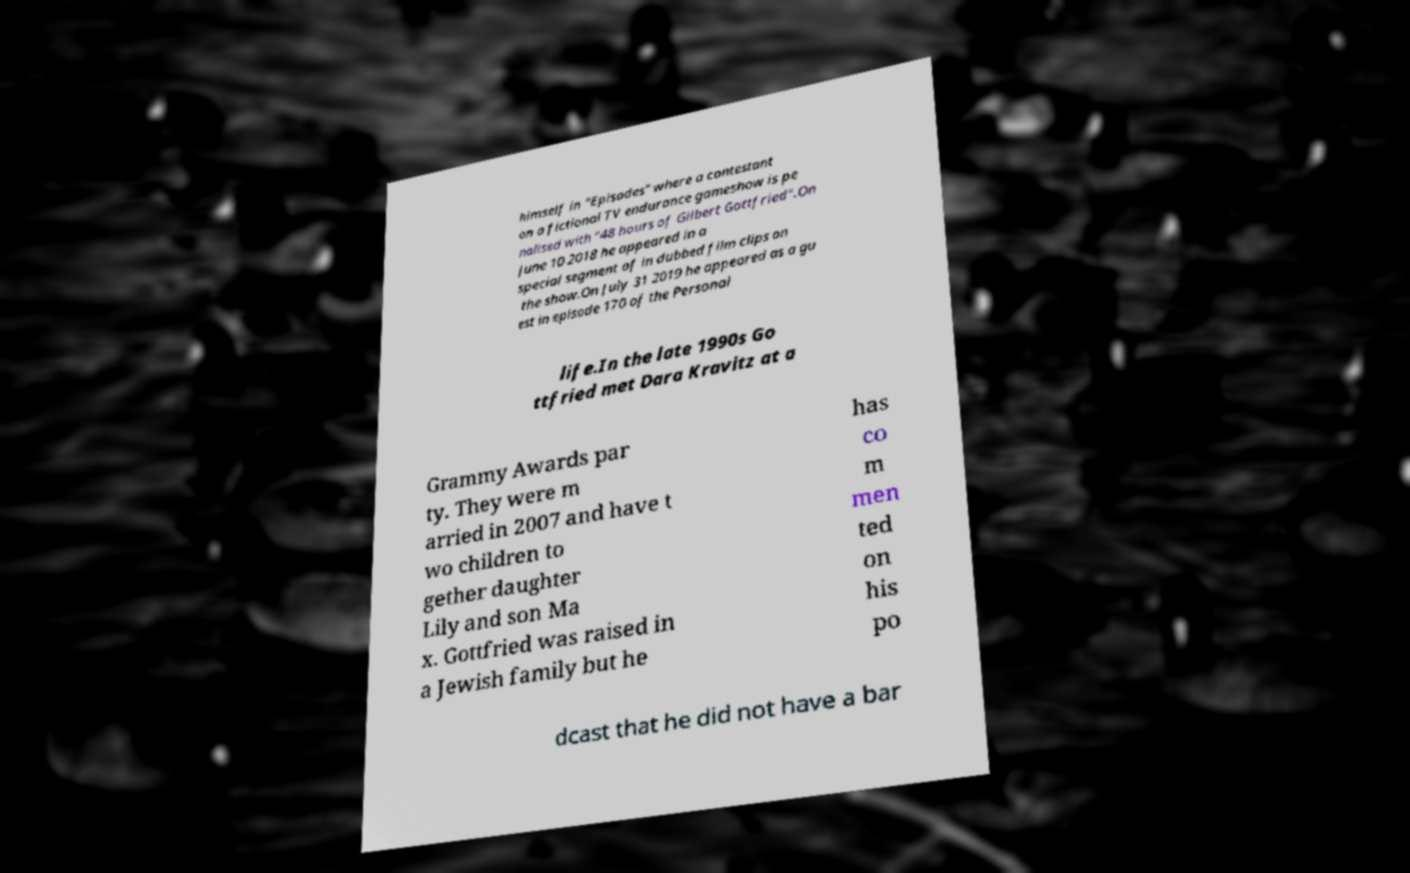For documentation purposes, I need the text within this image transcribed. Could you provide that? himself in "Episodes" where a contestant on a fictional TV endurance gameshow is pe nalised with "48 hours of Gilbert Gottfried".On June 10 2018 he appeared in a special segment of in dubbed film clips on the show.On July 31 2019 he appeared as a gu est in episode 170 of the Personal life.In the late 1990s Go ttfried met Dara Kravitz at a Grammy Awards par ty. They were m arried in 2007 and have t wo children to gether daughter Lily and son Ma x. Gottfried was raised in a Jewish family but he has co m men ted on his po dcast that he did not have a bar 